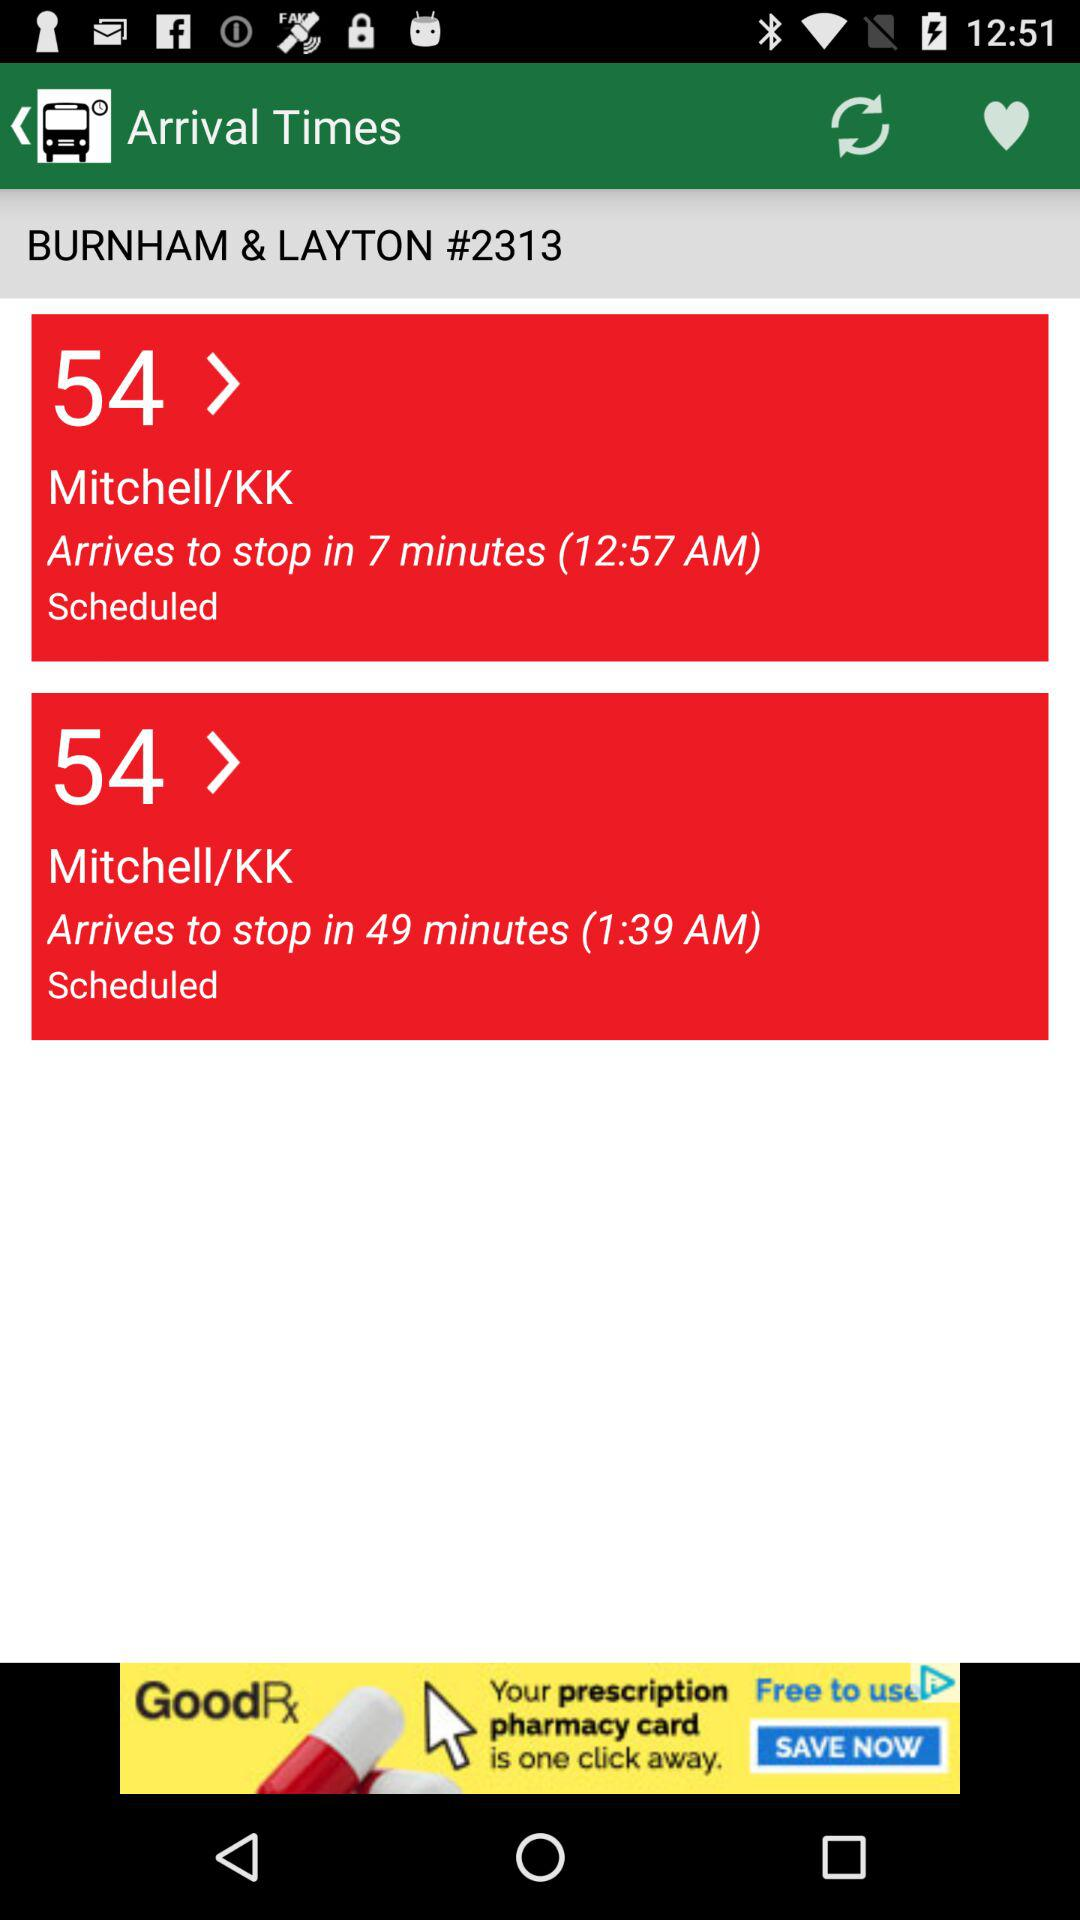What is the stoppage time?
When the provided information is insufficient, respond with <no answer>. <no answer> 